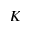Convert formula to latex. <formula><loc_0><loc_0><loc_500><loc_500>K</formula> 